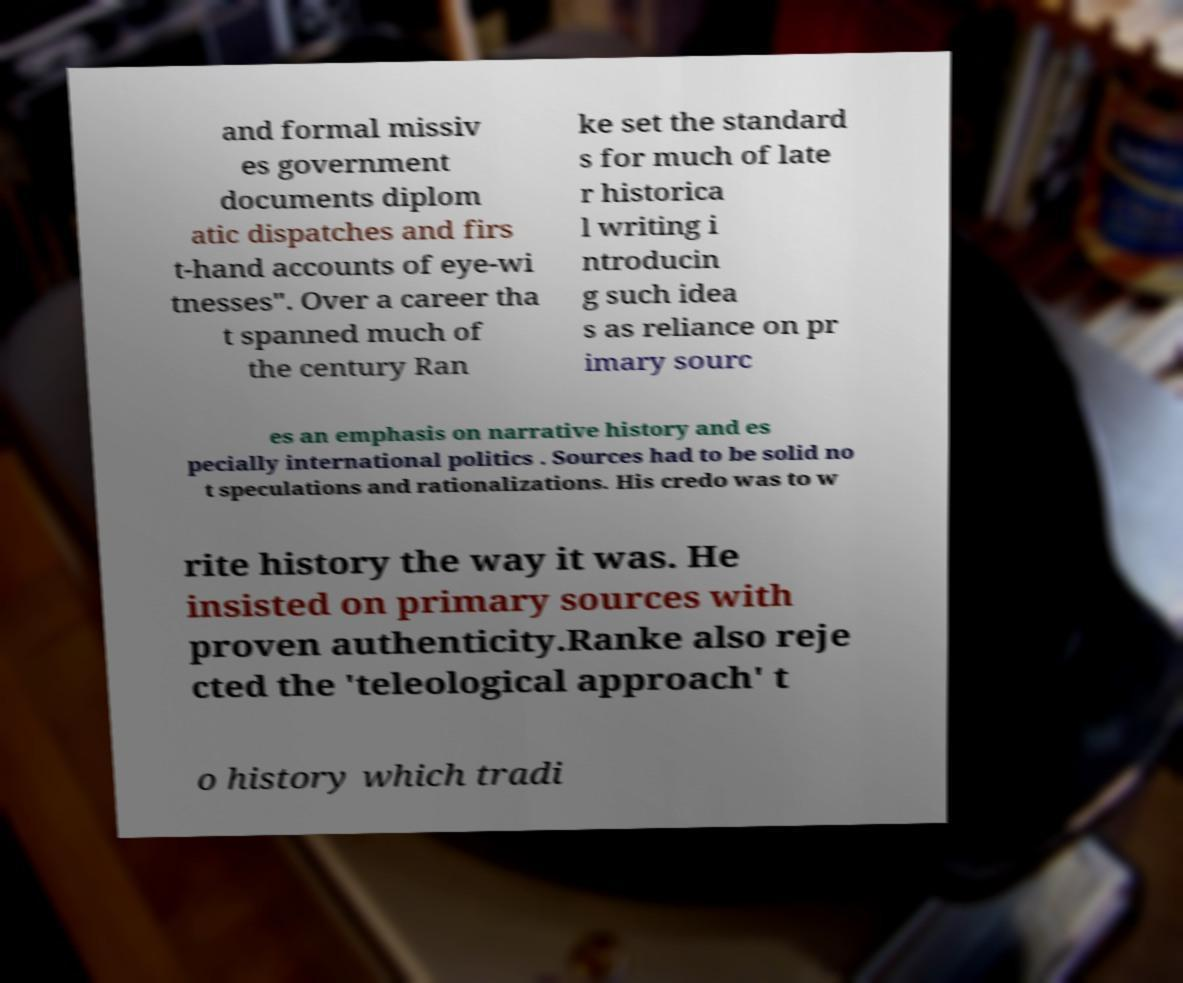Could you extract and type out the text from this image? and formal missiv es government documents diplom atic dispatches and firs t-hand accounts of eye-wi tnesses". Over a career tha t spanned much of the century Ran ke set the standard s for much of late r historica l writing i ntroducin g such idea s as reliance on pr imary sourc es an emphasis on narrative history and es pecially international politics . Sources had to be solid no t speculations and rationalizations. His credo was to w rite history the way it was. He insisted on primary sources with proven authenticity.Ranke also reje cted the 'teleological approach' t o history which tradi 